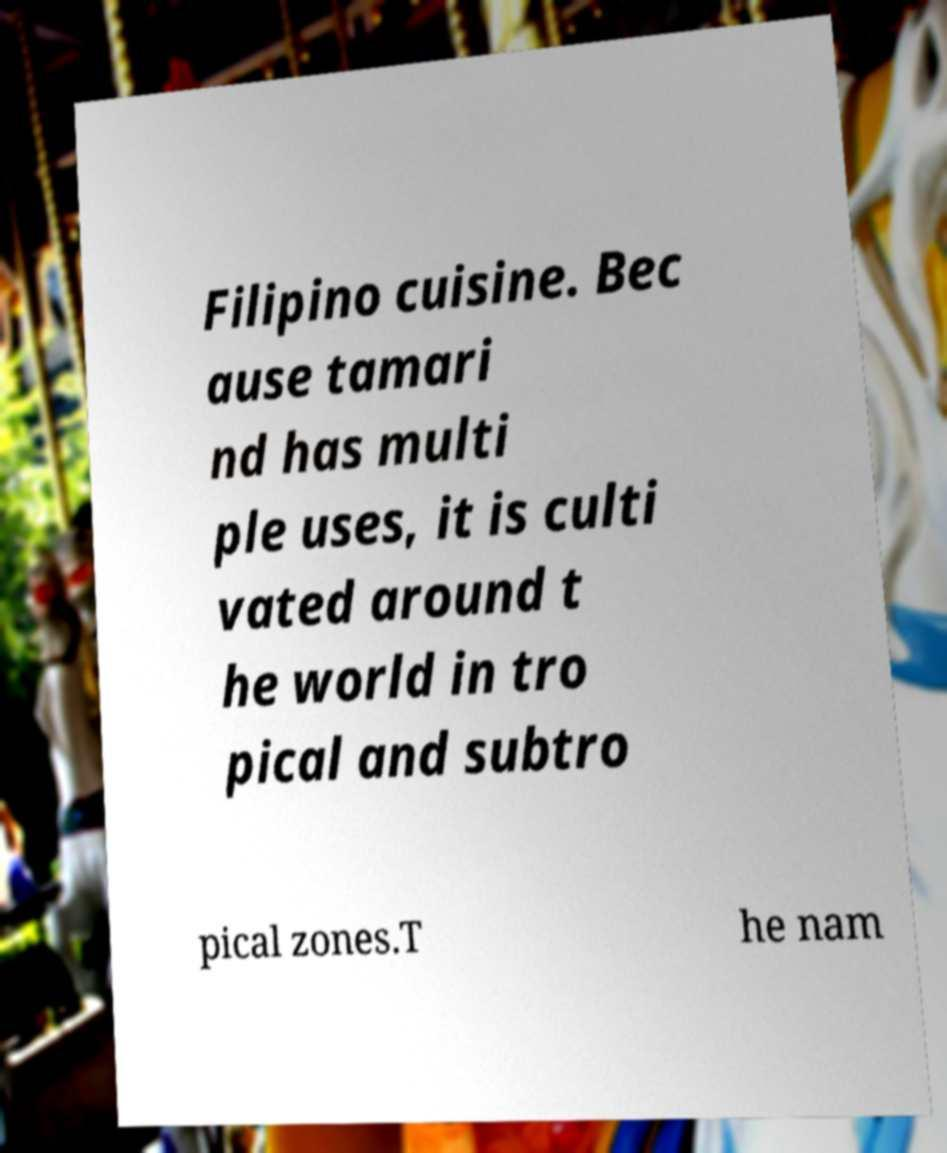Can you read and provide the text displayed in the image?This photo seems to have some interesting text. Can you extract and type it out for me? Filipino cuisine. Bec ause tamari nd has multi ple uses, it is culti vated around t he world in tro pical and subtro pical zones.T he nam 